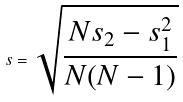<formula> <loc_0><loc_0><loc_500><loc_500>s = \sqrt { \frac { N s _ { 2 } - s _ { 1 } ^ { 2 } } { N ( N - 1 ) } }</formula> 